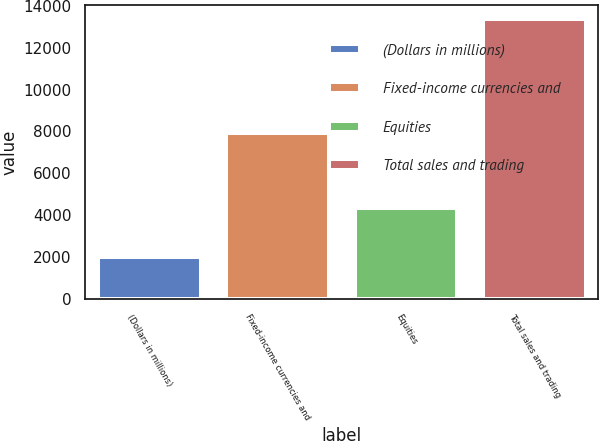<chart> <loc_0><loc_0><loc_500><loc_500><bar_chart><fcel>(Dollars in millions)<fcel>Fixed-income currencies and<fcel>Equities<fcel>Total sales and trading<nl><fcel>2015<fcel>7923<fcel>4335<fcel>13360.9<nl></chart> 